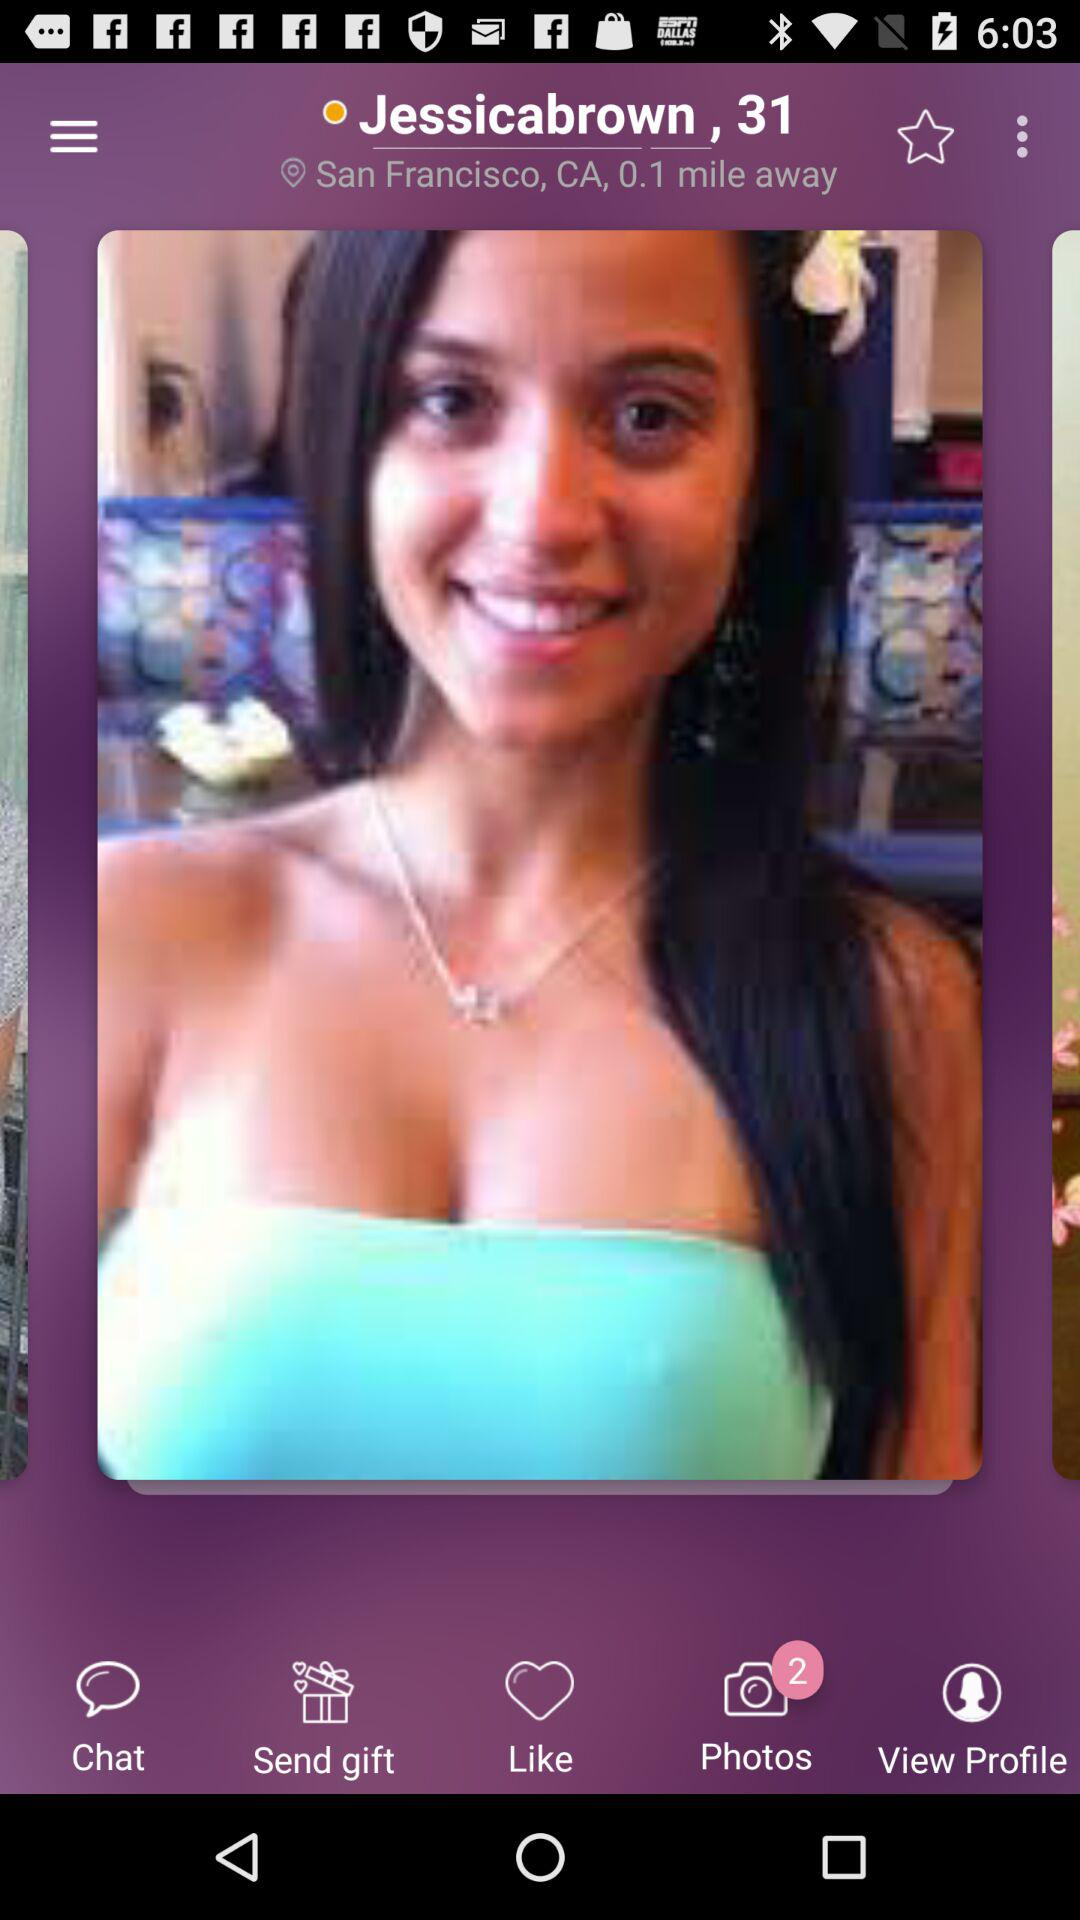What is the username? The username is "Jessicabrown". 